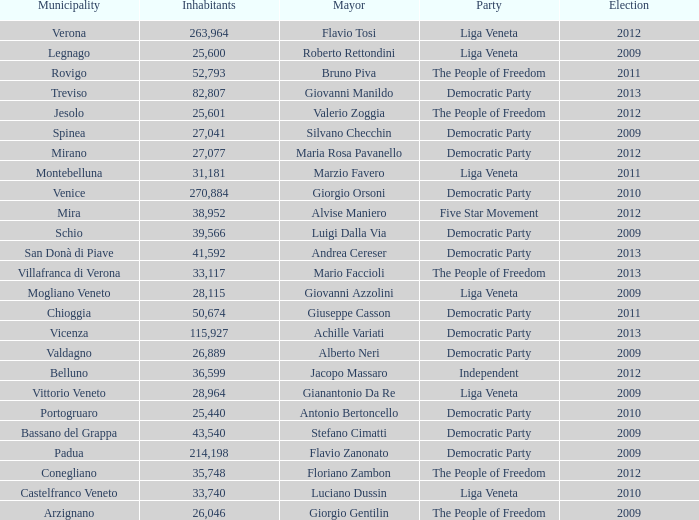How many elections had more than 36,599 inhabitants when Mayor was giovanni manildo? 1.0. 